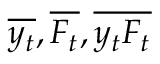<formula> <loc_0><loc_0><loc_500><loc_500>\overline { { y _ { t } } } , \overline { { F _ { t } } } , \overline { { y _ { t } F _ { t } } }</formula> 